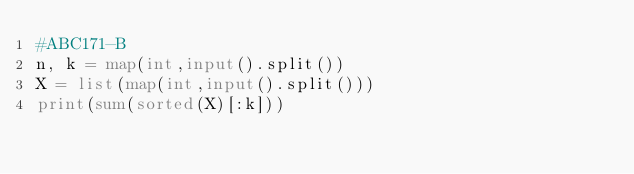Convert code to text. <code><loc_0><loc_0><loc_500><loc_500><_Python_>#ABC171-B
n, k = map(int,input().split())
X = list(map(int,input().split()))
print(sum(sorted(X)[:k]))</code> 